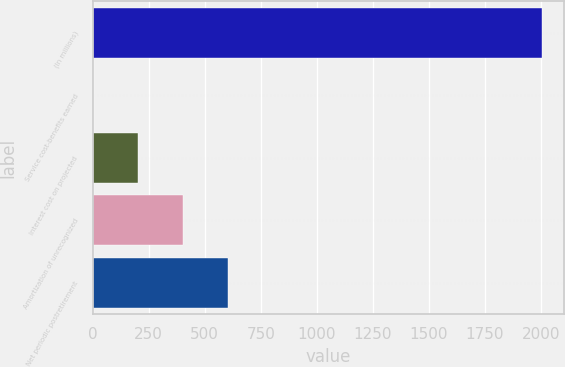Convert chart to OTSL. <chart><loc_0><loc_0><loc_500><loc_500><bar_chart><fcel>(In millions)<fcel>Service cost-benefits earned<fcel>Interest cost on projected<fcel>Amortization of unrecognized<fcel>Net periodic postretirement<nl><fcel>2004<fcel>2<fcel>202.2<fcel>402.4<fcel>602.6<nl></chart> 